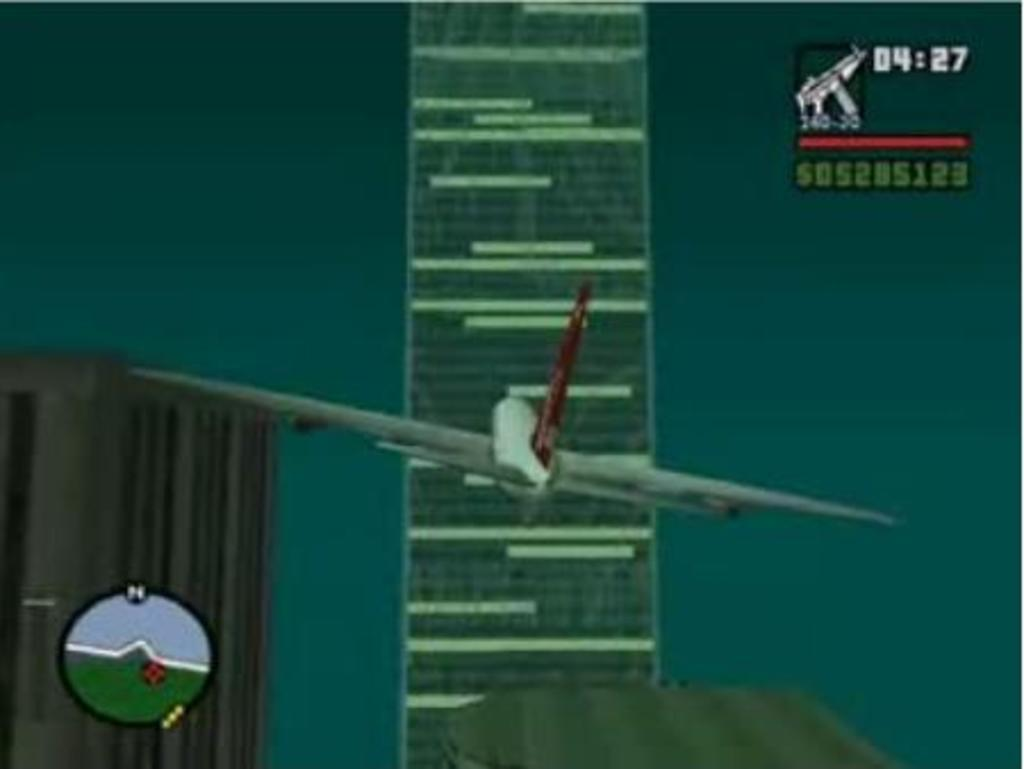<image>
Render a clear and concise summary of the photo. A screenshot from a videogame with the timer at 04:27 